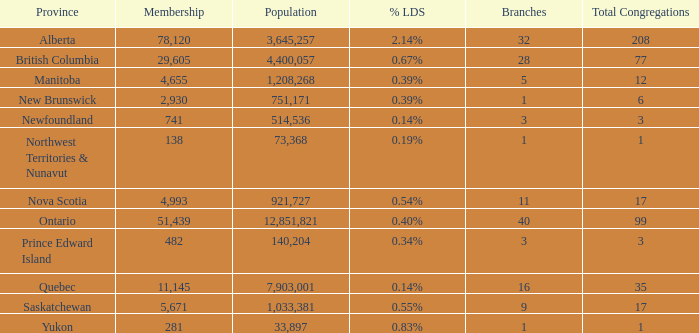What is the aggregate of the entire assembly in the manitoba province with fewer than 1,208,268 residents? None. 